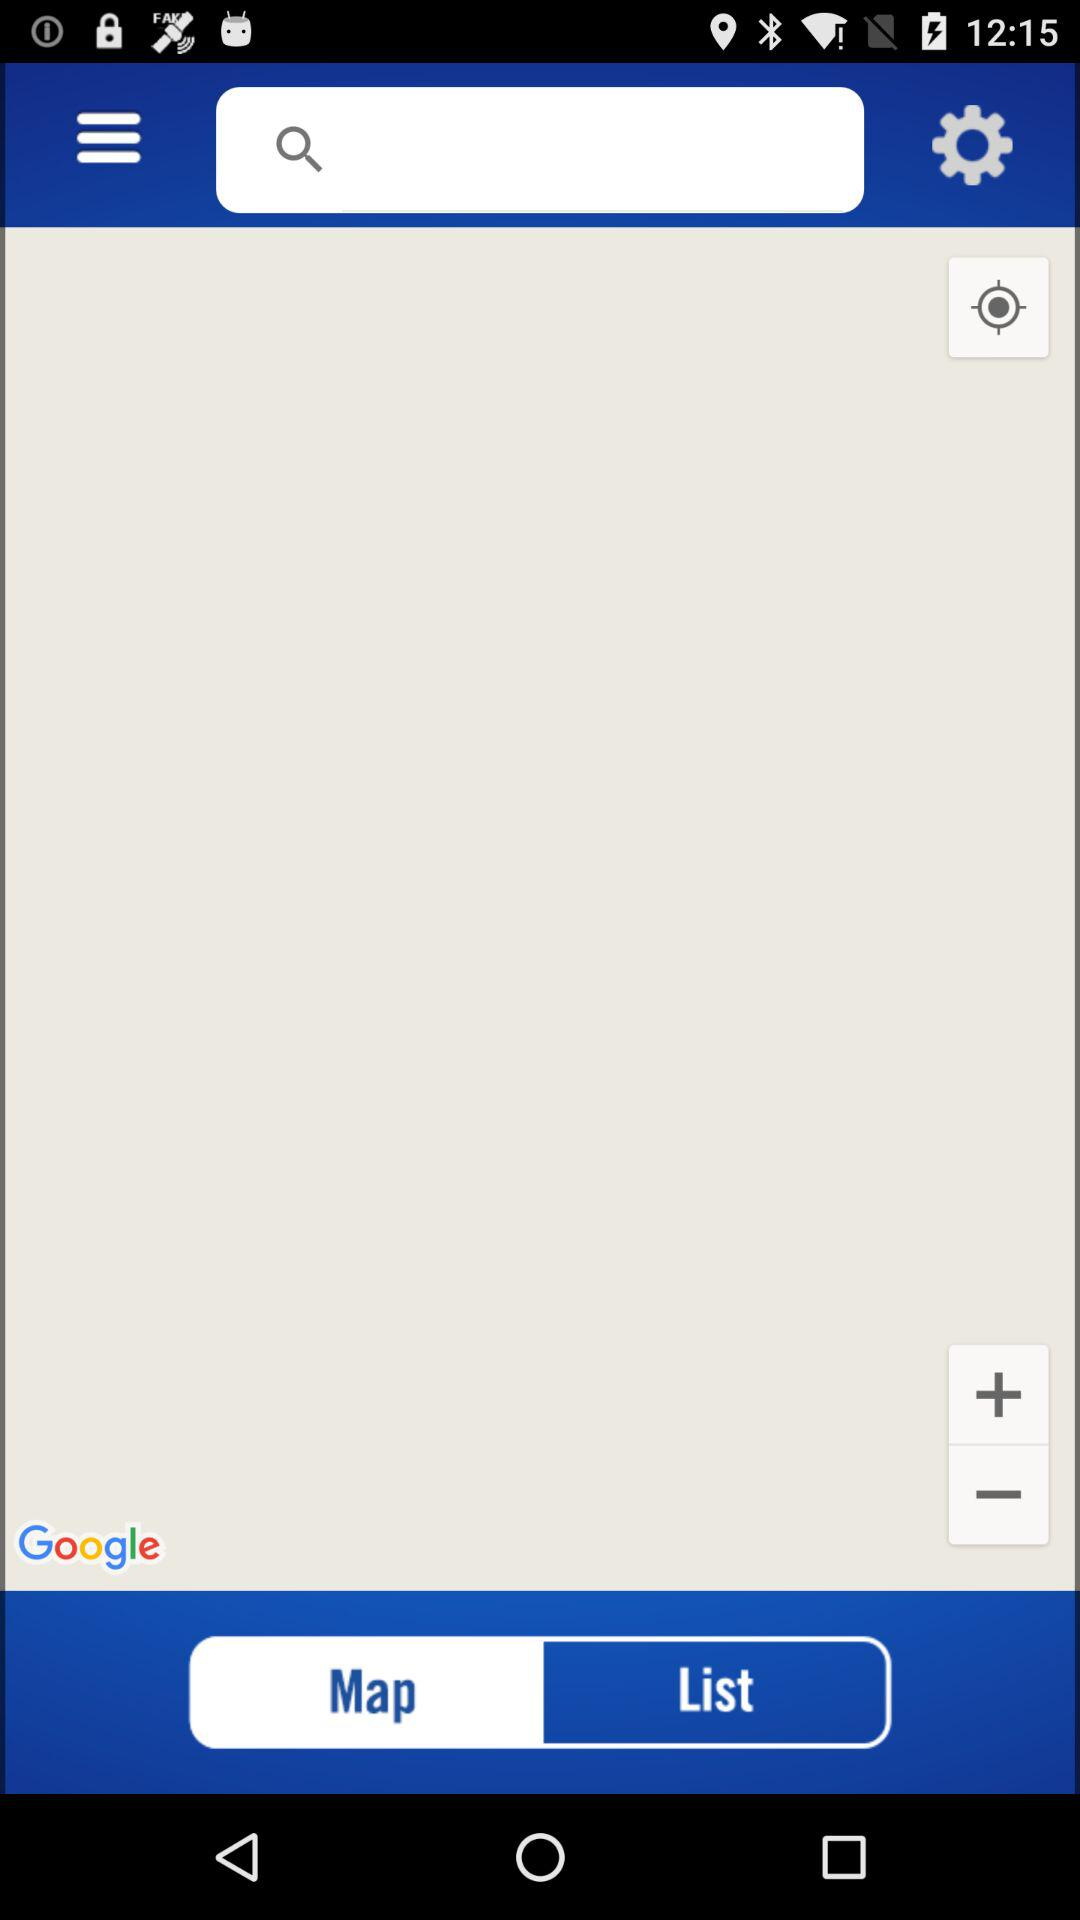Which tab is selected? The selected tab is "Map". 